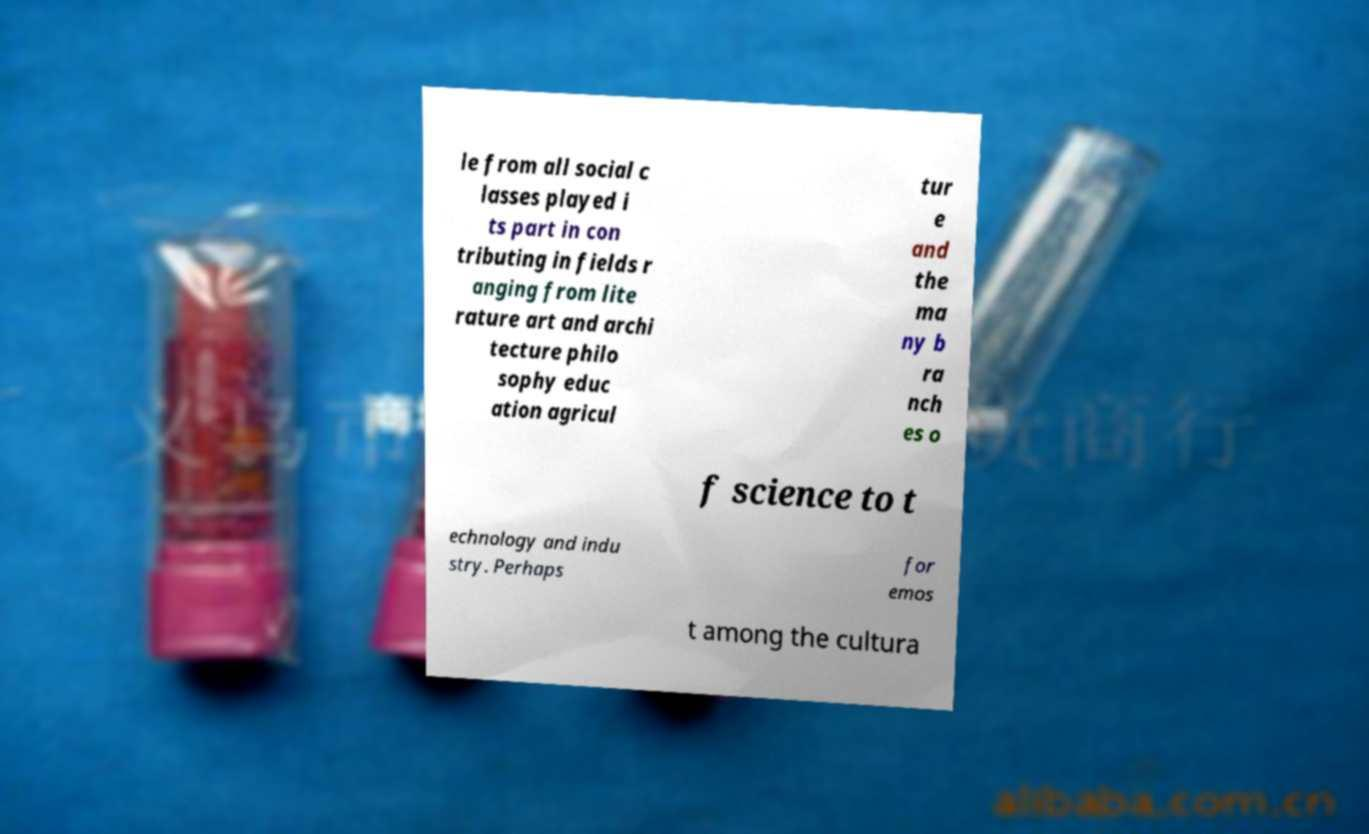Please read and relay the text visible in this image. What does it say? le from all social c lasses played i ts part in con tributing in fields r anging from lite rature art and archi tecture philo sophy educ ation agricul tur e and the ma ny b ra nch es o f science to t echnology and indu stry. Perhaps for emos t among the cultura 